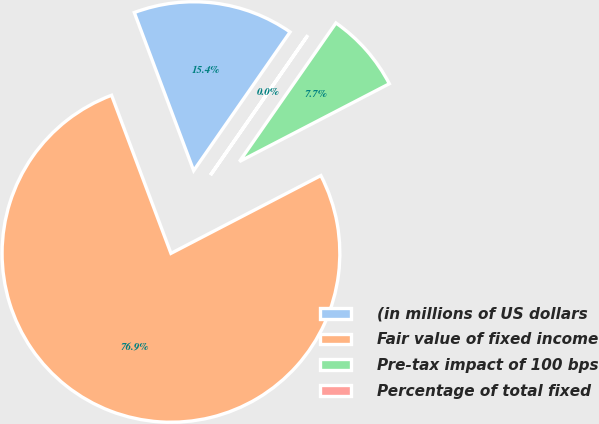Convert chart. <chart><loc_0><loc_0><loc_500><loc_500><pie_chart><fcel>(in millions of US dollars<fcel>Fair value of fixed income<fcel>Pre-tax impact of 100 bps<fcel>Percentage of total fixed<nl><fcel>15.39%<fcel>76.91%<fcel>7.7%<fcel>0.01%<nl></chart> 